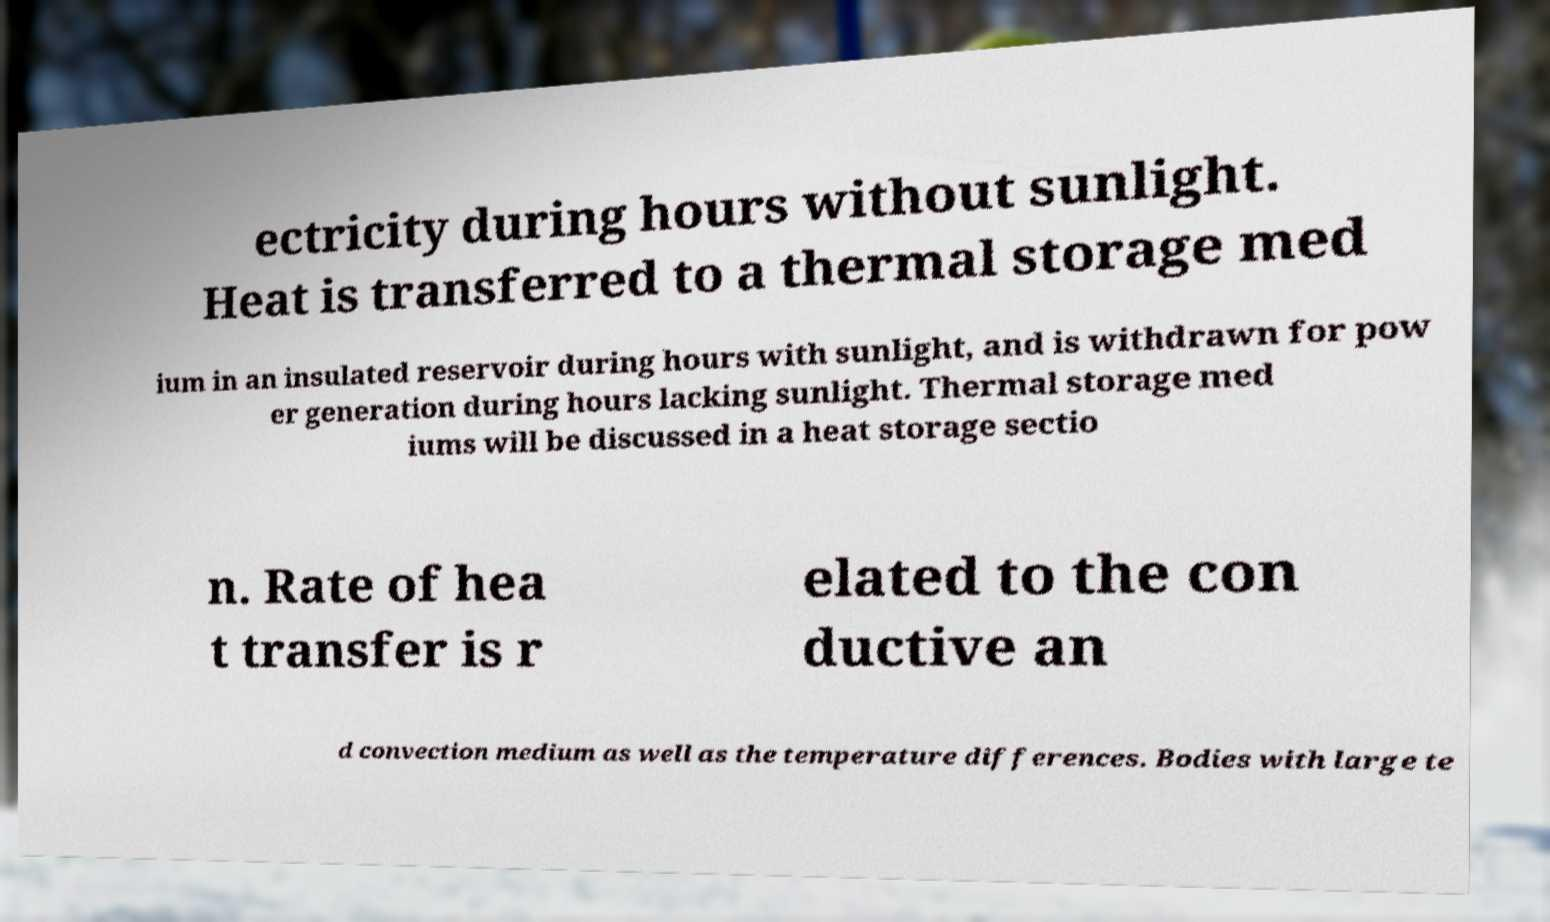Can you accurately transcribe the text from the provided image for me? ectricity during hours without sunlight. Heat is transferred to a thermal storage med ium in an insulated reservoir during hours with sunlight, and is withdrawn for pow er generation during hours lacking sunlight. Thermal storage med iums will be discussed in a heat storage sectio n. Rate of hea t transfer is r elated to the con ductive an d convection medium as well as the temperature differences. Bodies with large te 